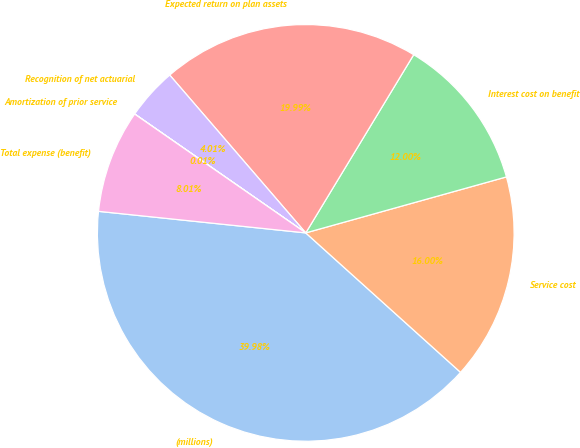Convert chart. <chart><loc_0><loc_0><loc_500><loc_500><pie_chart><fcel>(millions)<fcel>Service cost<fcel>Interest cost on benefit<fcel>Expected return on plan assets<fcel>Recognition of net actuarial<fcel>Amortization of prior service<fcel>Total expense (benefit)<nl><fcel>39.98%<fcel>16.0%<fcel>12.0%<fcel>19.99%<fcel>4.01%<fcel>0.01%<fcel>8.01%<nl></chart> 